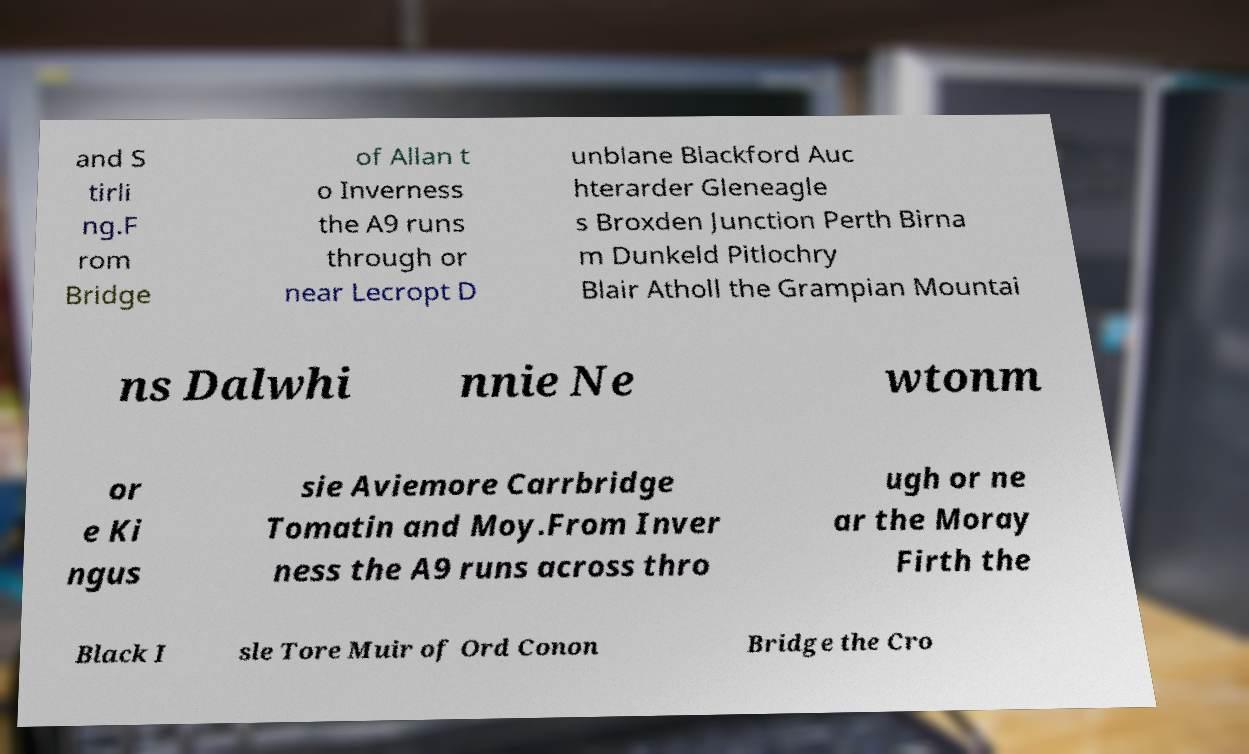For documentation purposes, I need the text within this image transcribed. Could you provide that? and S tirli ng.F rom Bridge of Allan t o Inverness the A9 runs through or near Lecropt D unblane Blackford Auc hterarder Gleneagle s Broxden Junction Perth Birna m Dunkeld Pitlochry Blair Atholl the Grampian Mountai ns Dalwhi nnie Ne wtonm or e Ki ngus sie Aviemore Carrbridge Tomatin and Moy.From Inver ness the A9 runs across thro ugh or ne ar the Moray Firth the Black I sle Tore Muir of Ord Conon Bridge the Cro 